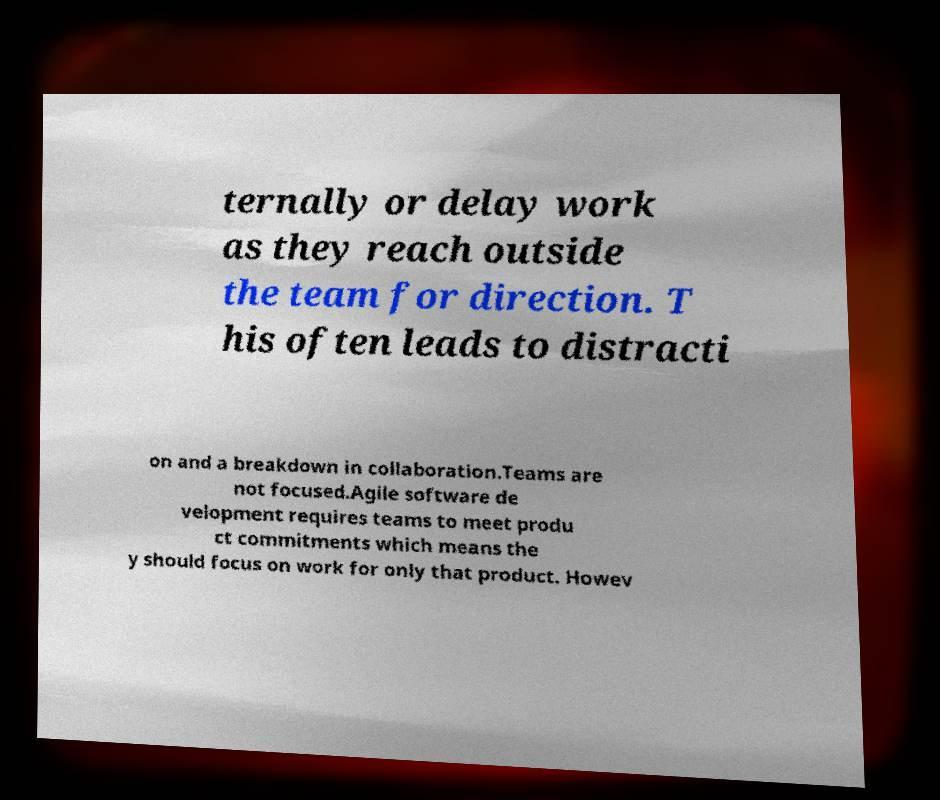There's text embedded in this image that I need extracted. Can you transcribe it verbatim? ternally or delay work as they reach outside the team for direction. T his often leads to distracti on and a breakdown in collaboration.Teams are not focused.Agile software de velopment requires teams to meet produ ct commitments which means the y should focus on work for only that product. Howev 